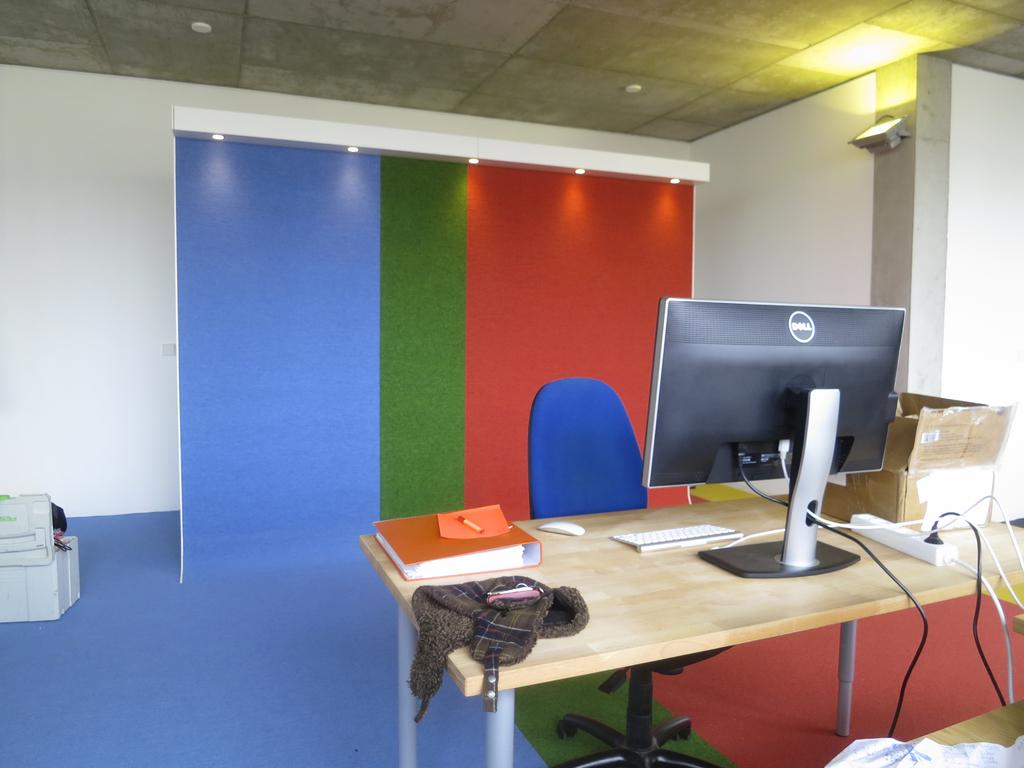<image>
Relay a brief, clear account of the picture shown. A dell monitor sitting on a wooden desk in front of a colorful backdrop. 